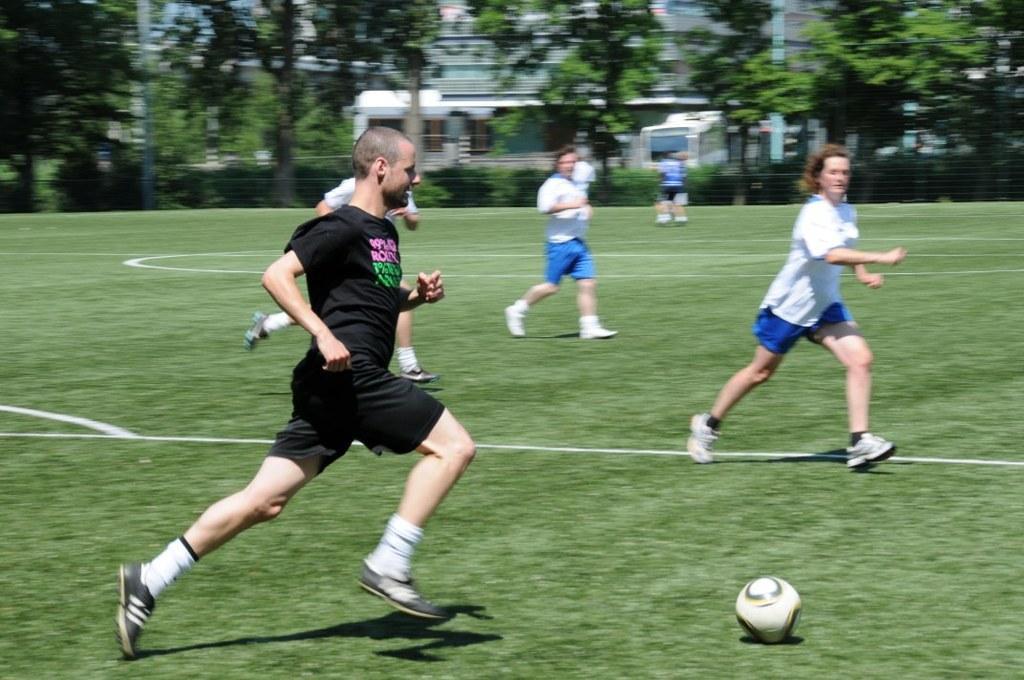Please provide a concise description of this image. In this image we can see some people and it looks like they are playing and we can see a ball on the ground. There are some trees and buildings and in the background the image is blurred. 